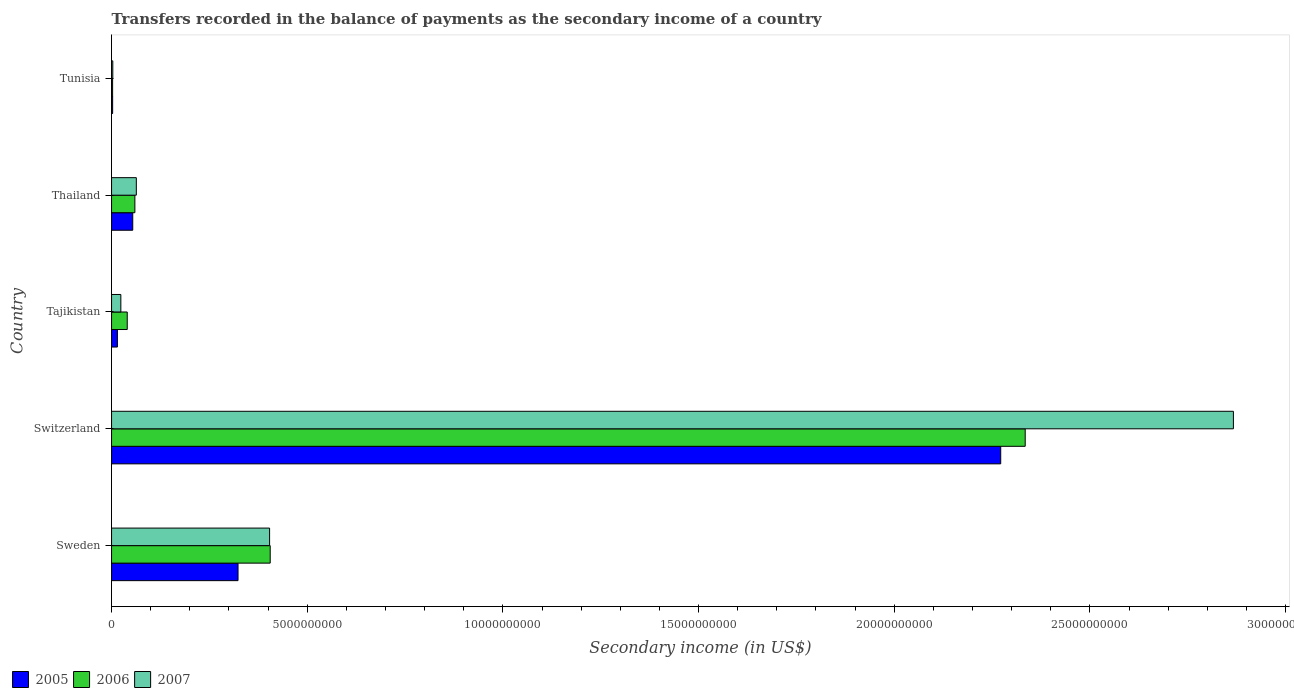How many different coloured bars are there?
Offer a very short reply. 3. How many bars are there on the 4th tick from the top?
Provide a short and direct response. 3. What is the label of the 3rd group of bars from the top?
Give a very brief answer. Tajikistan. In how many cases, is the number of bars for a given country not equal to the number of legend labels?
Offer a terse response. 0. What is the secondary income of in 2007 in Thailand?
Your answer should be compact. 6.33e+08. Across all countries, what is the maximum secondary income of in 2006?
Your answer should be very brief. 2.33e+1. Across all countries, what is the minimum secondary income of in 2006?
Provide a succinct answer. 2.70e+07. In which country was the secondary income of in 2006 maximum?
Your answer should be very brief. Switzerland. In which country was the secondary income of in 2007 minimum?
Your response must be concise. Tunisia. What is the total secondary income of in 2007 in the graph?
Provide a succinct answer. 3.36e+1. What is the difference between the secondary income of in 2007 in Switzerland and that in Tunisia?
Provide a short and direct response. 2.86e+1. What is the difference between the secondary income of in 2006 in Thailand and the secondary income of in 2005 in Sweden?
Provide a succinct answer. -2.64e+09. What is the average secondary income of in 2006 per country?
Ensure brevity in your answer.  5.68e+09. What is the difference between the secondary income of in 2007 and secondary income of in 2006 in Tajikistan?
Offer a terse response. -1.63e+08. In how many countries, is the secondary income of in 2005 greater than 12000000000 US$?
Provide a succinct answer. 1. What is the ratio of the secondary income of in 2007 in Sweden to that in Switzerland?
Keep it short and to the point. 0.14. What is the difference between the highest and the second highest secondary income of in 2005?
Offer a very short reply. 1.95e+1. What is the difference between the highest and the lowest secondary income of in 2007?
Offer a very short reply. 2.86e+1. What does the 2nd bar from the top in Switzerland represents?
Provide a short and direct response. 2006. What does the 2nd bar from the bottom in Switzerland represents?
Your answer should be very brief. 2006. How many bars are there?
Keep it short and to the point. 15. Are the values on the major ticks of X-axis written in scientific E-notation?
Give a very brief answer. No. Does the graph contain any zero values?
Keep it short and to the point. No. Where does the legend appear in the graph?
Offer a terse response. Bottom left. How are the legend labels stacked?
Offer a terse response. Horizontal. What is the title of the graph?
Offer a very short reply. Transfers recorded in the balance of payments as the secondary income of a country. Does "2013" appear as one of the legend labels in the graph?
Provide a short and direct response. No. What is the label or title of the X-axis?
Provide a succinct answer. Secondary income (in US$). What is the Secondary income (in US$) of 2005 in Sweden?
Your response must be concise. 3.23e+09. What is the Secondary income (in US$) in 2006 in Sweden?
Offer a very short reply. 4.05e+09. What is the Secondary income (in US$) of 2007 in Sweden?
Offer a very short reply. 4.04e+09. What is the Secondary income (in US$) of 2005 in Switzerland?
Ensure brevity in your answer.  2.27e+1. What is the Secondary income (in US$) in 2006 in Switzerland?
Give a very brief answer. 2.33e+1. What is the Secondary income (in US$) in 2007 in Switzerland?
Provide a short and direct response. 2.87e+1. What is the Secondary income (in US$) of 2005 in Tajikistan?
Your response must be concise. 1.50e+08. What is the Secondary income (in US$) of 2006 in Tajikistan?
Your answer should be very brief. 4.00e+08. What is the Secondary income (in US$) in 2007 in Tajikistan?
Make the answer very short. 2.37e+08. What is the Secondary income (in US$) in 2005 in Thailand?
Ensure brevity in your answer.  5.41e+08. What is the Secondary income (in US$) of 2006 in Thailand?
Offer a terse response. 5.96e+08. What is the Secondary income (in US$) in 2007 in Thailand?
Provide a short and direct response. 6.33e+08. What is the Secondary income (in US$) in 2005 in Tunisia?
Offer a very short reply. 2.77e+07. What is the Secondary income (in US$) in 2006 in Tunisia?
Your answer should be compact. 2.70e+07. What is the Secondary income (in US$) of 2007 in Tunisia?
Give a very brief answer. 3.15e+07. Across all countries, what is the maximum Secondary income (in US$) in 2005?
Provide a succinct answer. 2.27e+1. Across all countries, what is the maximum Secondary income (in US$) in 2006?
Your response must be concise. 2.33e+1. Across all countries, what is the maximum Secondary income (in US$) in 2007?
Keep it short and to the point. 2.87e+1. Across all countries, what is the minimum Secondary income (in US$) of 2005?
Ensure brevity in your answer.  2.77e+07. Across all countries, what is the minimum Secondary income (in US$) of 2006?
Ensure brevity in your answer.  2.70e+07. Across all countries, what is the minimum Secondary income (in US$) of 2007?
Give a very brief answer. 3.15e+07. What is the total Secondary income (in US$) in 2005 in the graph?
Ensure brevity in your answer.  2.67e+1. What is the total Secondary income (in US$) in 2006 in the graph?
Provide a succinct answer. 2.84e+1. What is the total Secondary income (in US$) in 2007 in the graph?
Make the answer very short. 3.36e+1. What is the difference between the Secondary income (in US$) in 2005 in Sweden and that in Switzerland?
Make the answer very short. -1.95e+1. What is the difference between the Secondary income (in US$) in 2006 in Sweden and that in Switzerland?
Offer a terse response. -1.93e+1. What is the difference between the Secondary income (in US$) of 2007 in Sweden and that in Switzerland?
Your response must be concise. -2.46e+1. What is the difference between the Secondary income (in US$) of 2005 in Sweden and that in Tajikistan?
Ensure brevity in your answer.  3.08e+09. What is the difference between the Secondary income (in US$) in 2006 in Sweden and that in Tajikistan?
Your response must be concise. 3.65e+09. What is the difference between the Secondary income (in US$) in 2007 in Sweden and that in Tajikistan?
Provide a succinct answer. 3.80e+09. What is the difference between the Secondary income (in US$) in 2005 in Sweden and that in Thailand?
Your answer should be compact. 2.69e+09. What is the difference between the Secondary income (in US$) of 2006 in Sweden and that in Thailand?
Keep it short and to the point. 3.46e+09. What is the difference between the Secondary income (in US$) in 2007 in Sweden and that in Thailand?
Your answer should be compact. 3.41e+09. What is the difference between the Secondary income (in US$) of 2005 in Sweden and that in Tunisia?
Provide a succinct answer. 3.20e+09. What is the difference between the Secondary income (in US$) in 2006 in Sweden and that in Tunisia?
Your response must be concise. 4.03e+09. What is the difference between the Secondary income (in US$) of 2007 in Sweden and that in Tunisia?
Your answer should be compact. 4.01e+09. What is the difference between the Secondary income (in US$) of 2005 in Switzerland and that in Tajikistan?
Your answer should be very brief. 2.26e+1. What is the difference between the Secondary income (in US$) in 2006 in Switzerland and that in Tajikistan?
Keep it short and to the point. 2.29e+1. What is the difference between the Secondary income (in US$) in 2007 in Switzerland and that in Tajikistan?
Provide a succinct answer. 2.84e+1. What is the difference between the Secondary income (in US$) in 2005 in Switzerland and that in Thailand?
Ensure brevity in your answer.  2.22e+1. What is the difference between the Secondary income (in US$) in 2006 in Switzerland and that in Thailand?
Your answer should be very brief. 2.28e+1. What is the difference between the Secondary income (in US$) in 2007 in Switzerland and that in Thailand?
Keep it short and to the point. 2.80e+1. What is the difference between the Secondary income (in US$) of 2005 in Switzerland and that in Tunisia?
Provide a succinct answer. 2.27e+1. What is the difference between the Secondary income (in US$) of 2006 in Switzerland and that in Tunisia?
Keep it short and to the point. 2.33e+1. What is the difference between the Secondary income (in US$) in 2007 in Switzerland and that in Tunisia?
Your answer should be very brief. 2.86e+1. What is the difference between the Secondary income (in US$) in 2005 in Tajikistan and that in Thailand?
Give a very brief answer. -3.91e+08. What is the difference between the Secondary income (in US$) of 2006 in Tajikistan and that in Thailand?
Provide a succinct answer. -1.96e+08. What is the difference between the Secondary income (in US$) of 2007 in Tajikistan and that in Thailand?
Ensure brevity in your answer.  -3.96e+08. What is the difference between the Secondary income (in US$) in 2005 in Tajikistan and that in Tunisia?
Your answer should be very brief. 1.22e+08. What is the difference between the Secondary income (in US$) in 2006 in Tajikistan and that in Tunisia?
Keep it short and to the point. 3.73e+08. What is the difference between the Secondary income (in US$) in 2007 in Tajikistan and that in Tunisia?
Keep it short and to the point. 2.06e+08. What is the difference between the Secondary income (in US$) of 2005 in Thailand and that in Tunisia?
Your response must be concise. 5.14e+08. What is the difference between the Secondary income (in US$) of 2006 in Thailand and that in Tunisia?
Provide a short and direct response. 5.69e+08. What is the difference between the Secondary income (in US$) of 2007 in Thailand and that in Tunisia?
Make the answer very short. 6.01e+08. What is the difference between the Secondary income (in US$) in 2005 in Sweden and the Secondary income (in US$) in 2006 in Switzerland?
Keep it short and to the point. -2.01e+1. What is the difference between the Secondary income (in US$) of 2005 in Sweden and the Secondary income (in US$) of 2007 in Switzerland?
Give a very brief answer. -2.54e+1. What is the difference between the Secondary income (in US$) in 2006 in Sweden and the Secondary income (in US$) in 2007 in Switzerland?
Offer a terse response. -2.46e+1. What is the difference between the Secondary income (in US$) in 2005 in Sweden and the Secondary income (in US$) in 2006 in Tajikistan?
Provide a succinct answer. 2.83e+09. What is the difference between the Secondary income (in US$) of 2005 in Sweden and the Secondary income (in US$) of 2007 in Tajikistan?
Your answer should be compact. 2.99e+09. What is the difference between the Secondary income (in US$) of 2006 in Sweden and the Secondary income (in US$) of 2007 in Tajikistan?
Make the answer very short. 3.82e+09. What is the difference between the Secondary income (in US$) in 2005 in Sweden and the Secondary income (in US$) in 2006 in Thailand?
Your answer should be compact. 2.64e+09. What is the difference between the Secondary income (in US$) of 2005 in Sweden and the Secondary income (in US$) of 2007 in Thailand?
Keep it short and to the point. 2.60e+09. What is the difference between the Secondary income (in US$) of 2006 in Sweden and the Secondary income (in US$) of 2007 in Thailand?
Offer a very short reply. 3.42e+09. What is the difference between the Secondary income (in US$) of 2005 in Sweden and the Secondary income (in US$) of 2006 in Tunisia?
Make the answer very short. 3.20e+09. What is the difference between the Secondary income (in US$) in 2005 in Sweden and the Secondary income (in US$) in 2007 in Tunisia?
Ensure brevity in your answer.  3.20e+09. What is the difference between the Secondary income (in US$) of 2006 in Sweden and the Secondary income (in US$) of 2007 in Tunisia?
Provide a succinct answer. 4.02e+09. What is the difference between the Secondary income (in US$) of 2005 in Switzerland and the Secondary income (in US$) of 2006 in Tajikistan?
Make the answer very short. 2.23e+1. What is the difference between the Secondary income (in US$) of 2005 in Switzerland and the Secondary income (in US$) of 2007 in Tajikistan?
Your answer should be very brief. 2.25e+1. What is the difference between the Secondary income (in US$) in 2006 in Switzerland and the Secondary income (in US$) in 2007 in Tajikistan?
Make the answer very short. 2.31e+1. What is the difference between the Secondary income (in US$) in 2005 in Switzerland and the Secondary income (in US$) in 2006 in Thailand?
Your answer should be very brief. 2.21e+1. What is the difference between the Secondary income (in US$) in 2005 in Switzerland and the Secondary income (in US$) in 2007 in Thailand?
Provide a short and direct response. 2.21e+1. What is the difference between the Secondary income (in US$) of 2006 in Switzerland and the Secondary income (in US$) of 2007 in Thailand?
Your answer should be very brief. 2.27e+1. What is the difference between the Secondary income (in US$) in 2005 in Switzerland and the Secondary income (in US$) in 2006 in Tunisia?
Provide a short and direct response. 2.27e+1. What is the difference between the Secondary income (in US$) of 2005 in Switzerland and the Secondary income (in US$) of 2007 in Tunisia?
Offer a very short reply. 2.27e+1. What is the difference between the Secondary income (in US$) of 2006 in Switzerland and the Secondary income (in US$) of 2007 in Tunisia?
Make the answer very short. 2.33e+1. What is the difference between the Secondary income (in US$) in 2005 in Tajikistan and the Secondary income (in US$) in 2006 in Thailand?
Provide a succinct answer. -4.46e+08. What is the difference between the Secondary income (in US$) of 2005 in Tajikistan and the Secondary income (in US$) of 2007 in Thailand?
Ensure brevity in your answer.  -4.83e+08. What is the difference between the Secondary income (in US$) in 2006 in Tajikistan and the Secondary income (in US$) in 2007 in Thailand?
Offer a very short reply. -2.33e+08. What is the difference between the Secondary income (in US$) of 2005 in Tajikistan and the Secondary income (in US$) of 2006 in Tunisia?
Provide a short and direct response. 1.23e+08. What is the difference between the Secondary income (in US$) in 2005 in Tajikistan and the Secondary income (in US$) in 2007 in Tunisia?
Your answer should be very brief. 1.18e+08. What is the difference between the Secondary income (in US$) of 2006 in Tajikistan and the Secondary income (in US$) of 2007 in Tunisia?
Give a very brief answer. 3.69e+08. What is the difference between the Secondary income (in US$) in 2005 in Thailand and the Secondary income (in US$) in 2006 in Tunisia?
Your answer should be very brief. 5.14e+08. What is the difference between the Secondary income (in US$) of 2005 in Thailand and the Secondary income (in US$) of 2007 in Tunisia?
Provide a succinct answer. 5.10e+08. What is the difference between the Secondary income (in US$) of 2006 in Thailand and the Secondary income (in US$) of 2007 in Tunisia?
Provide a succinct answer. 5.64e+08. What is the average Secondary income (in US$) of 2005 per country?
Give a very brief answer. 5.33e+09. What is the average Secondary income (in US$) of 2006 per country?
Make the answer very short. 5.68e+09. What is the average Secondary income (in US$) in 2007 per country?
Give a very brief answer. 6.72e+09. What is the difference between the Secondary income (in US$) of 2005 and Secondary income (in US$) of 2006 in Sweden?
Your response must be concise. -8.22e+08. What is the difference between the Secondary income (in US$) of 2005 and Secondary income (in US$) of 2007 in Sweden?
Your response must be concise. -8.06e+08. What is the difference between the Secondary income (in US$) in 2006 and Secondary income (in US$) in 2007 in Sweden?
Your answer should be very brief. 1.58e+07. What is the difference between the Secondary income (in US$) in 2005 and Secondary income (in US$) in 2006 in Switzerland?
Offer a terse response. -6.26e+08. What is the difference between the Secondary income (in US$) of 2005 and Secondary income (in US$) of 2007 in Switzerland?
Give a very brief answer. -5.95e+09. What is the difference between the Secondary income (in US$) in 2006 and Secondary income (in US$) in 2007 in Switzerland?
Provide a short and direct response. -5.32e+09. What is the difference between the Secondary income (in US$) of 2005 and Secondary income (in US$) of 2006 in Tajikistan?
Give a very brief answer. -2.50e+08. What is the difference between the Secondary income (in US$) of 2005 and Secondary income (in US$) of 2007 in Tajikistan?
Keep it short and to the point. -8.72e+07. What is the difference between the Secondary income (in US$) of 2006 and Secondary income (in US$) of 2007 in Tajikistan?
Your answer should be very brief. 1.63e+08. What is the difference between the Secondary income (in US$) of 2005 and Secondary income (in US$) of 2006 in Thailand?
Ensure brevity in your answer.  -5.44e+07. What is the difference between the Secondary income (in US$) of 2005 and Secondary income (in US$) of 2007 in Thailand?
Make the answer very short. -9.15e+07. What is the difference between the Secondary income (in US$) in 2006 and Secondary income (in US$) in 2007 in Thailand?
Your answer should be very brief. -3.71e+07. What is the difference between the Secondary income (in US$) of 2005 and Secondary income (in US$) of 2006 in Tunisia?
Your response must be concise. 6.23e+05. What is the difference between the Secondary income (in US$) in 2005 and Secondary income (in US$) in 2007 in Tunisia?
Ensure brevity in your answer.  -3.86e+06. What is the difference between the Secondary income (in US$) of 2006 and Secondary income (in US$) of 2007 in Tunisia?
Make the answer very short. -4.48e+06. What is the ratio of the Secondary income (in US$) of 2005 in Sweden to that in Switzerland?
Give a very brief answer. 0.14. What is the ratio of the Secondary income (in US$) in 2006 in Sweden to that in Switzerland?
Provide a short and direct response. 0.17. What is the ratio of the Secondary income (in US$) in 2007 in Sweden to that in Switzerland?
Your answer should be very brief. 0.14. What is the ratio of the Secondary income (in US$) of 2005 in Sweden to that in Tajikistan?
Give a very brief answer. 21.55. What is the ratio of the Secondary income (in US$) of 2006 in Sweden to that in Tajikistan?
Provide a succinct answer. 10.13. What is the ratio of the Secondary income (in US$) of 2007 in Sweden to that in Tajikistan?
Your response must be concise. 17.03. What is the ratio of the Secondary income (in US$) of 2005 in Sweden to that in Thailand?
Make the answer very short. 5.97. What is the ratio of the Secondary income (in US$) in 2006 in Sweden to that in Thailand?
Offer a very short reply. 6.8. What is the ratio of the Secondary income (in US$) of 2007 in Sweden to that in Thailand?
Offer a terse response. 6.38. What is the ratio of the Secondary income (in US$) in 2005 in Sweden to that in Tunisia?
Give a very brief answer. 116.8. What is the ratio of the Secondary income (in US$) of 2006 in Sweden to that in Tunisia?
Provide a succinct answer. 149.89. What is the ratio of the Secondary income (in US$) in 2007 in Sweden to that in Tunisia?
Your answer should be very brief. 128.08. What is the ratio of the Secondary income (in US$) in 2005 in Switzerland to that in Tajikistan?
Make the answer very short. 151.49. What is the ratio of the Secondary income (in US$) of 2006 in Switzerland to that in Tajikistan?
Your response must be concise. 58.31. What is the ratio of the Secondary income (in US$) of 2007 in Switzerland to that in Tajikistan?
Your answer should be compact. 120.89. What is the ratio of the Secondary income (in US$) in 2005 in Switzerland to that in Thailand?
Give a very brief answer. 41.96. What is the ratio of the Secondary income (in US$) of 2006 in Switzerland to that in Thailand?
Offer a terse response. 39.18. What is the ratio of the Secondary income (in US$) of 2007 in Switzerland to that in Thailand?
Ensure brevity in your answer.  45.29. What is the ratio of the Secondary income (in US$) in 2005 in Switzerland to that in Tunisia?
Give a very brief answer. 821.15. What is the ratio of the Secondary income (in US$) of 2006 in Switzerland to that in Tunisia?
Make the answer very short. 863.2. What is the ratio of the Secondary income (in US$) of 2007 in Switzerland to that in Tunisia?
Your answer should be compact. 909.22. What is the ratio of the Secondary income (in US$) in 2005 in Tajikistan to that in Thailand?
Offer a very short reply. 0.28. What is the ratio of the Secondary income (in US$) of 2006 in Tajikistan to that in Thailand?
Provide a short and direct response. 0.67. What is the ratio of the Secondary income (in US$) of 2007 in Tajikistan to that in Thailand?
Offer a terse response. 0.37. What is the ratio of the Secondary income (in US$) of 2005 in Tajikistan to that in Tunisia?
Your answer should be compact. 5.42. What is the ratio of the Secondary income (in US$) of 2006 in Tajikistan to that in Tunisia?
Provide a succinct answer. 14.8. What is the ratio of the Secondary income (in US$) in 2007 in Tajikistan to that in Tunisia?
Your answer should be very brief. 7.52. What is the ratio of the Secondary income (in US$) of 2005 in Thailand to that in Tunisia?
Your answer should be very brief. 19.57. What is the ratio of the Secondary income (in US$) of 2006 in Thailand to that in Tunisia?
Keep it short and to the point. 22.03. What is the ratio of the Secondary income (in US$) in 2007 in Thailand to that in Tunisia?
Offer a very short reply. 20.08. What is the difference between the highest and the second highest Secondary income (in US$) in 2005?
Your response must be concise. 1.95e+1. What is the difference between the highest and the second highest Secondary income (in US$) in 2006?
Provide a succinct answer. 1.93e+1. What is the difference between the highest and the second highest Secondary income (in US$) in 2007?
Your answer should be compact. 2.46e+1. What is the difference between the highest and the lowest Secondary income (in US$) in 2005?
Keep it short and to the point. 2.27e+1. What is the difference between the highest and the lowest Secondary income (in US$) in 2006?
Your answer should be very brief. 2.33e+1. What is the difference between the highest and the lowest Secondary income (in US$) of 2007?
Offer a very short reply. 2.86e+1. 